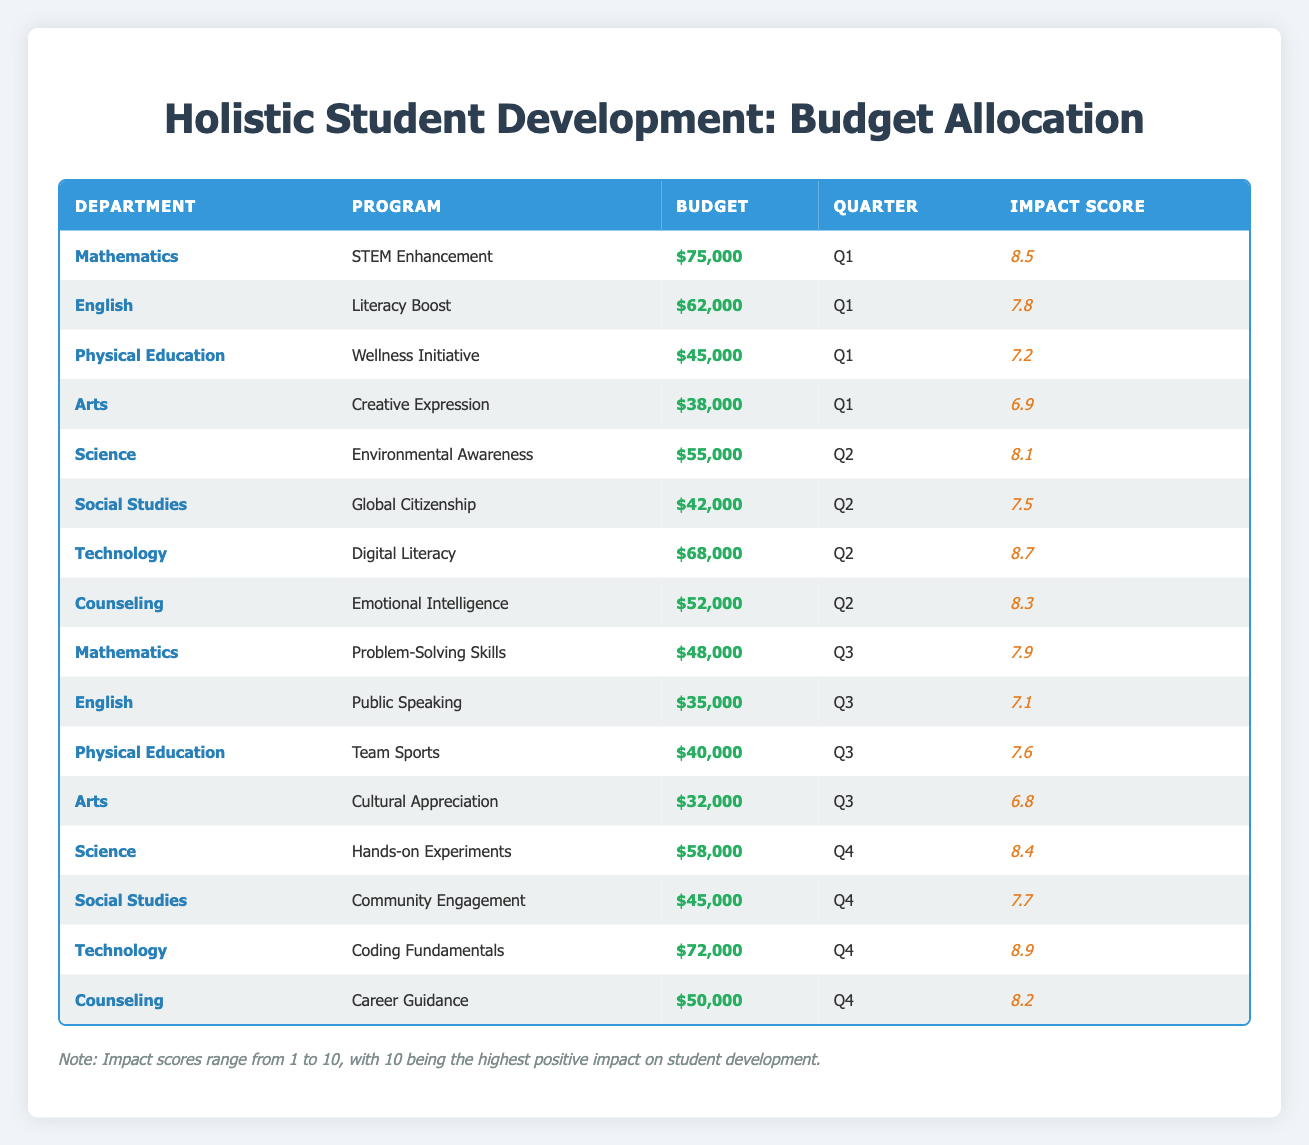What is the total budget allocated for the Technology department in 2023? The Technology department has budgets of 68,000 in Q2 and 72,000 in Q4. Adding these together gives 68,000 + 72,000 = 140,000.
Answer: 140,000 Which program under the Counseling department has the highest impact score? The Counseling department has two programs: Emotional Intelligence with an impact score of 8.3 and Career Guidance with an impact score of 8.2. The higher impact score is 8.3 for Emotional Intelligence.
Answer: Emotional Intelligence Is the budget for the Physical Education department in Q3 greater than the budget in Q1? The budget for Physical Education in Q1 is 45,000, while in Q3 it is 40,000. Since 40,000 is not greater than 45,000, the statement is false.
Answer: No What is the average impact score for programs in the Arts department? The Arts department has two programs: Creative Expression with an impact score of 6.9 and Cultural Appreciation with an impact score of 6.8. The average is (6.9 + 6.8) / 2 = 6.85.
Answer: 6.85 Which quarter had the highest budget allocation for the Science department? The Science department has budgets of 55,000 in Q2 and 58,000 in Q4. Comparing these, the highest is 58,000 in Q4.
Answer: Q4 How many departments received a budget allocation of over 70,000 in 2023? The budget allocations over 70,000 are for Mathematics (75,000), Technology (68,000 in Q2 and 72,000 in Q4), and the greatest is Technology at 72,000. Counting only those over 70,000 gives us 2 total departments: Mathematics and Technology.
Answer: 2 Which department had the lowest overall budget in 2023? By examining the total budgets, Arts received 38,000 in Q1 and 32,000 in Q3, totaling 70,000. The lowest overall budget across departments is 70,000 for Arts.
Answer: Arts Did the budget allocation for the English department increase in Q2 compared to Q1? The budget for English in Q1 is 62,000, while it's not listed in Q2. There is no increase since it was reduced to 35,000 in Q3. Therefore, this statement is true or false.
Answer: No What is the difference in budget allocation between the Counseling programs, Emotional Intelligence and Career Guidance? Emotional Intelligence has a budget of 52,000 and Career Guidance has a budget of 50,000. The difference is calculated as 52,000 - 50,000 = 2,000.
Answer: 2,000 